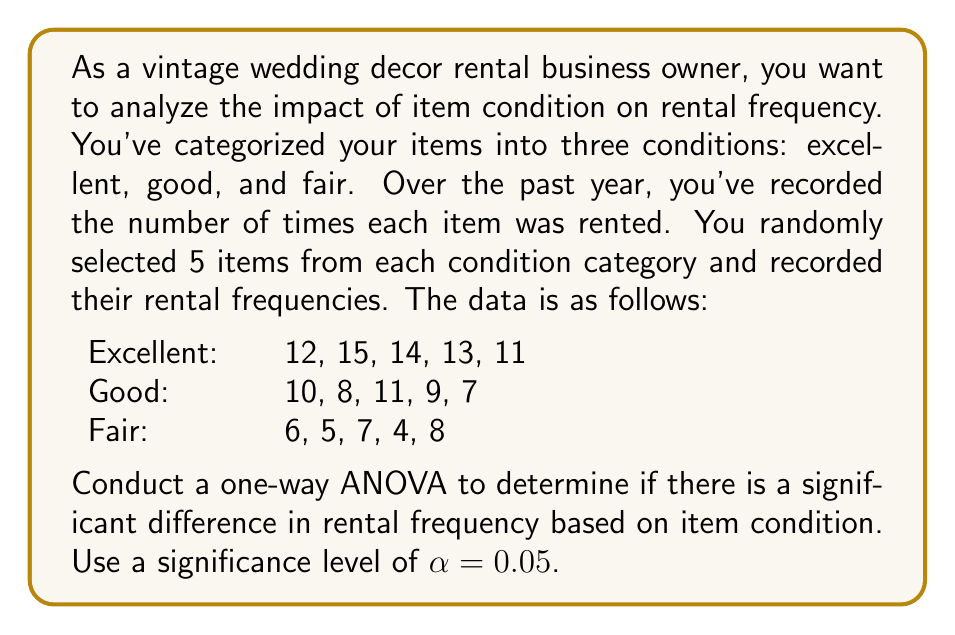What is the answer to this math problem? To conduct a one-way ANOVA, we'll follow these steps:

1. Calculate the sum of squares between groups (SSB), within groups (SSW), and total (SST).
2. Calculate the degrees of freedom for between groups (dfB), within groups (dfW), and total (dfT).
3. Calculate the mean squares for between groups (MSB) and within groups (MSW).
4. Calculate the F-statistic.
5. Compare the F-statistic to the critical F-value.

Step 1: Calculate sum of squares

First, we need to calculate the grand mean:
$$\bar{X} = \frac{12+15+14+13+11+10+8+11+9+7+6+5+7+4+8}{15} = 9.33$$

Now, we can calculate SSB, SSW, and SST:

SSB:
$$SSB = 5[(12.6-9.33)^2 + (9-9.33)^2 + (6-9.33)^2] = 136.13$$

SSW:
$$SSW = [(12-12.6)^2 + (15-12.6)^2 + (14-12.6)^2 + (13-12.6)^2 + (11-12.6)^2] + \\
[(10-9)^2 + (8-9)^2 + (11-9)^2 + (9-9)^2 + (7-9)^2] + \\
[(6-6)^2 + (5-6)^2 + (7-6)^2 + (4-6)^2 + (8-6)^2] = 39.2$$

SST:
$$SST = SSB + SSW = 136.13 + 39.2 = 175.33$$

Step 2: Calculate degrees of freedom

dfB = number of groups - 1 = 3 - 1 = 2
dfW = total number of observations - number of groups = 15 - 3 = 12
dfT = total number of observations - 1 = 15 - 1 = 14

Step 3: Calculate mean squares

$$MSB = \frac{SSB}{dfB} = \frac{136.13}{2} = 68.065$$
$$MSW = \frac{SSW}{dfW} = \frac{39.2}{12} = 3.267$$

Step 4: Calculate F-statistic

$$F = \frac{MSB}{MSW} = \frac{68.065}{3.267} = 20.83$$

Step 5: Compare F-statistic to critical F-value

The critical F-value for $\alpha = 0.05$, dfB = 2, and dfW = 12 is approximately 3.89.

Since our calculated F-statistic (20.83) is greater than the critical F-value (3.89), we reject the null hypothesis.
Answer: The one-way ANOVA results show a significant difference in rental frequency based on item condition (F(2,12) = 20.83, p < 0.05). We reject the null hypothesis and conclude that the condition of the vintage wedding decor items (excellent, good, or fair) has a significant impact on their rental frequency. 